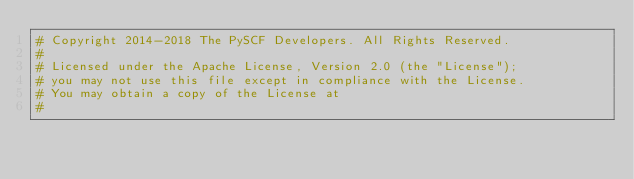Convert code to text. <code><loc_0><loc_0><loc_500><loc_500><_Python_># Copyright 2014-2018 The PySCF Developers. All Rights Reserved.
#
# Licensed under the Apache License, Version 2.0 (the "License");
# you may not use this file except in compliance with the License.
# You may obtain a copy of the License at
#</code> 